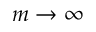Convert formula to latex. <formula><loc_0><loc_0><loc_500><loc_500>m \rightarrow \infty</formula> 